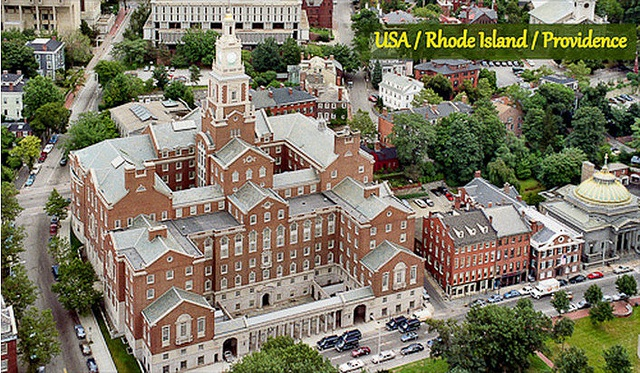Describe the objects in this image and their specific colors. I can see car in ivory, darkgray, black, gray, and lightgray tones, truck in ivory, white, darkgray, gray, and black tones, car in ivory, black, gray, navy, and darkgray tones, car in ivory, black, gray, navy, and blue tones, and car in ivory, lightgray, darkgray, black, and gray tones in this image. 